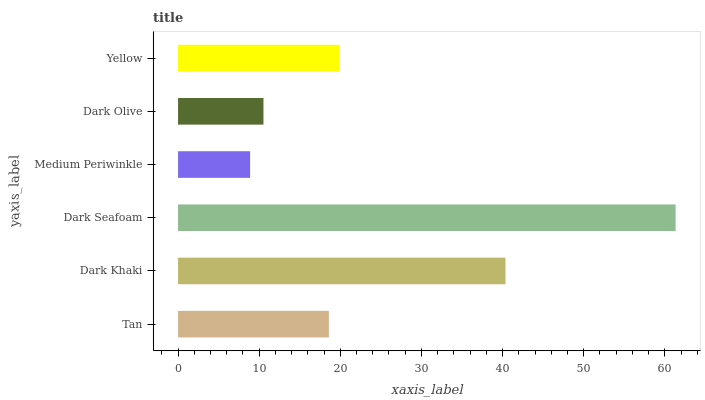Is Medium Periwinkle the minimum?
Answer yes or no. Yes. Is Dark Seafoam the maximum?
Answer yes or no. Yes. Is Dark Khaki the minimum?
Answer yes or no. No. Is Dark Khaki the maximum?
Answer yes or no. No. Is Dark Khaki greater than Tan?
Answer yes or no. Yes. Is Tan less than Dark Khaki?
Answer yes or no. Yes. Is Tan greater than Dark Khaki?
Answer yes or no. No. Is Dark Khaki less than Tan?
Answer yes or no. No. Is Yellow the high median?
Answer yes or no. Yes. Is Tan the low median?
Answer yes or no. Yes. Is Tan the high median?
Answer yes or no. No. Is Dark Olive the low median?
Answer yes or no. No. 